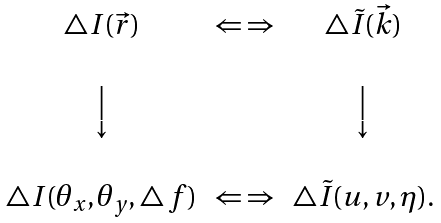Convert formula to latex. <formula><loc_0><loc_0><loc_500><loc_500>\begin{array} { c c c } \triangle I ( \vec { r } ) & { \Leftarrow \, \Rightarrow } & \triangle \tilde { I } ( \vec { k } ) \\ \\ \Big \downarrow & & \Big \downarrow \\ \\ \triangle I ( \theta _ { x } , \theta _ { y } , \triangle \, f ) & \Leftarrow \, \Rightarrow & \triangle \tilde { I } ( u , v , \eta ) . \end{array}</formula> 